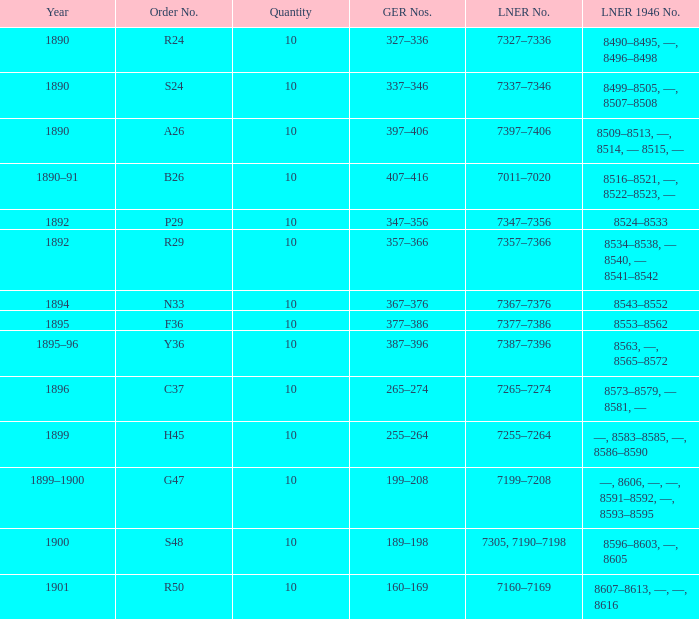Which LNER 1946 number is from 1892 and has an LNER number of 7347–7356? 8524–8533. 